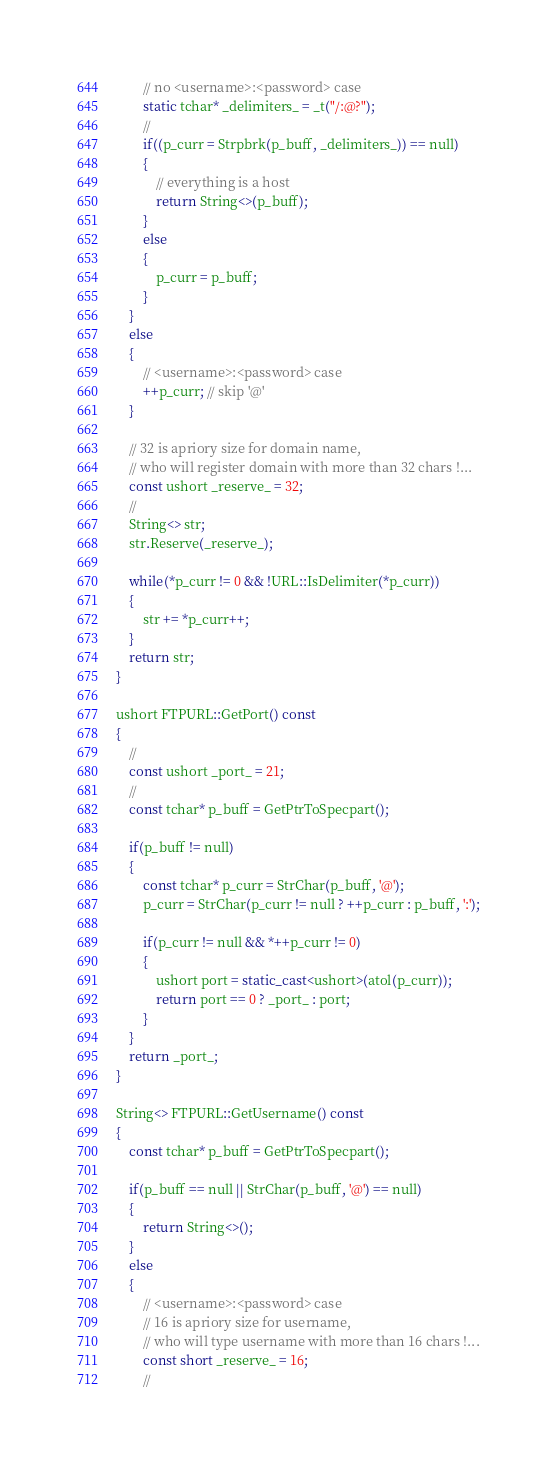Convert code to text. <code><loc_0><loc_0><loc_500><loc_500><_C++_>        // no <username>:<password> case
        static tchar* _delimiters_ = _t("/:@?");
        //
        if((p_curr = Strpbrk(p_buff, _delimiters_)) == null)
        {
            // everything is a host
            return String<>(p_buff);
        }
        else
        {
            p_curr = p_buff;
        }
    }
    else
    {
        // <username>:<password> case
        ++p_curr; // skip '@'
    }

    // 32 is apriory size for domain name,
    // who will register domain with more than 32 chars !...
    const ushort _reserve_ = 32;
    //
    String<> str;
    str.Reserve(_reserve_);

    while(*p_curr != 0 && !URL::IsDelimiter(*p_curr))
    {
        str += *p_curr++;
    }
    return str;
}

ushort FTPURL::GetPort() const
{
    //
    const ushort _port_ = 21;
    //
    const tchar* p_buff = GetPtrToSpecpart();

    if(p_buff != null)
    {
        const tchar* p_curr = StrChar(p_buff, '@');
        p_curr = StrChar(p_curr != null ? ++p_curr : p_buff, ':');

        if(p_curr != null && *++p_curr != 0)
        {
            ushort port = static_cast<ushort>(atol(p_curr));
            return port == 0 ? _port_ : port;
        }
    }
    return _port_;
}

String<> FTPURL::GetUsername() const
{
    const tchar* p_buff = GetPtrToSpecpart();

    if(p_buff == null || StrChar(p_buff, '@') == null)
    {
        return String<>();
    }
    else
    {
        // <username>:<password> case
        // 16 is apriory size for username,
        // who will type username with more than 16 chars !...
        const short _reserve_ = 16;
        //</code> 